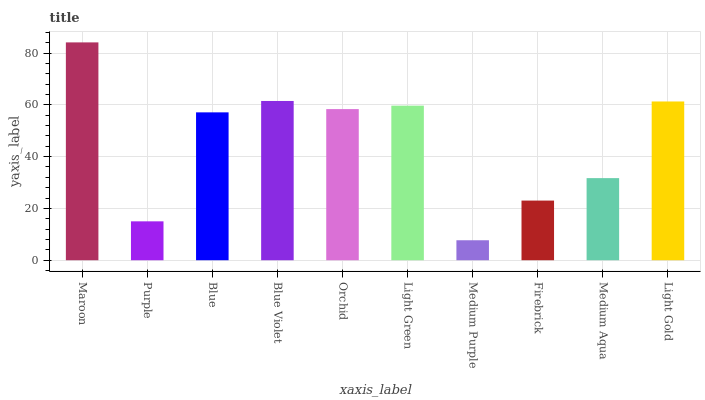Is Medium Purple the minimum?
Answer yes or no. Yes. Is Maroon the maximum?
Answer yes or no. Yes. Is Purple the minimum?
Answer yes or no. No. Is Purple the maximum?
Answer yes or no. No. Is Maroon greater than Purple?
Answer yes or no. Yes. Is Purple less than Maroon?
Answer yes or no. Yes. Is Purple greater than Maroon?
Answer yes or no. No. Is Maroon less than Purple?
Answer yes or no. No. Is Orchid the high median?
Answer yes or no. Yes. Is Blue the low median?
Answer yes or no. Yes. Is Purple the high median?
Answer yes or no. No. Is Light Gold the low median?
Answer yes or no. No. 